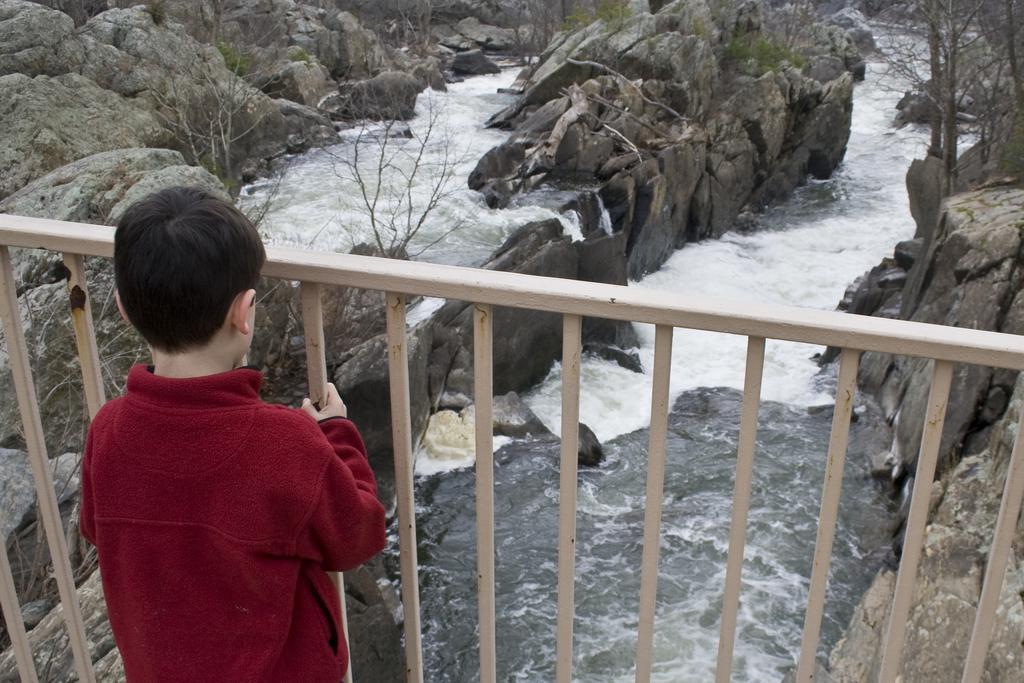In one or two sentences, can you explain what this image depicts? In this image I can see a boy wearing a maroon color t-shirt and standing in front of the fence and at the top I can see the hill and tree and water lake 